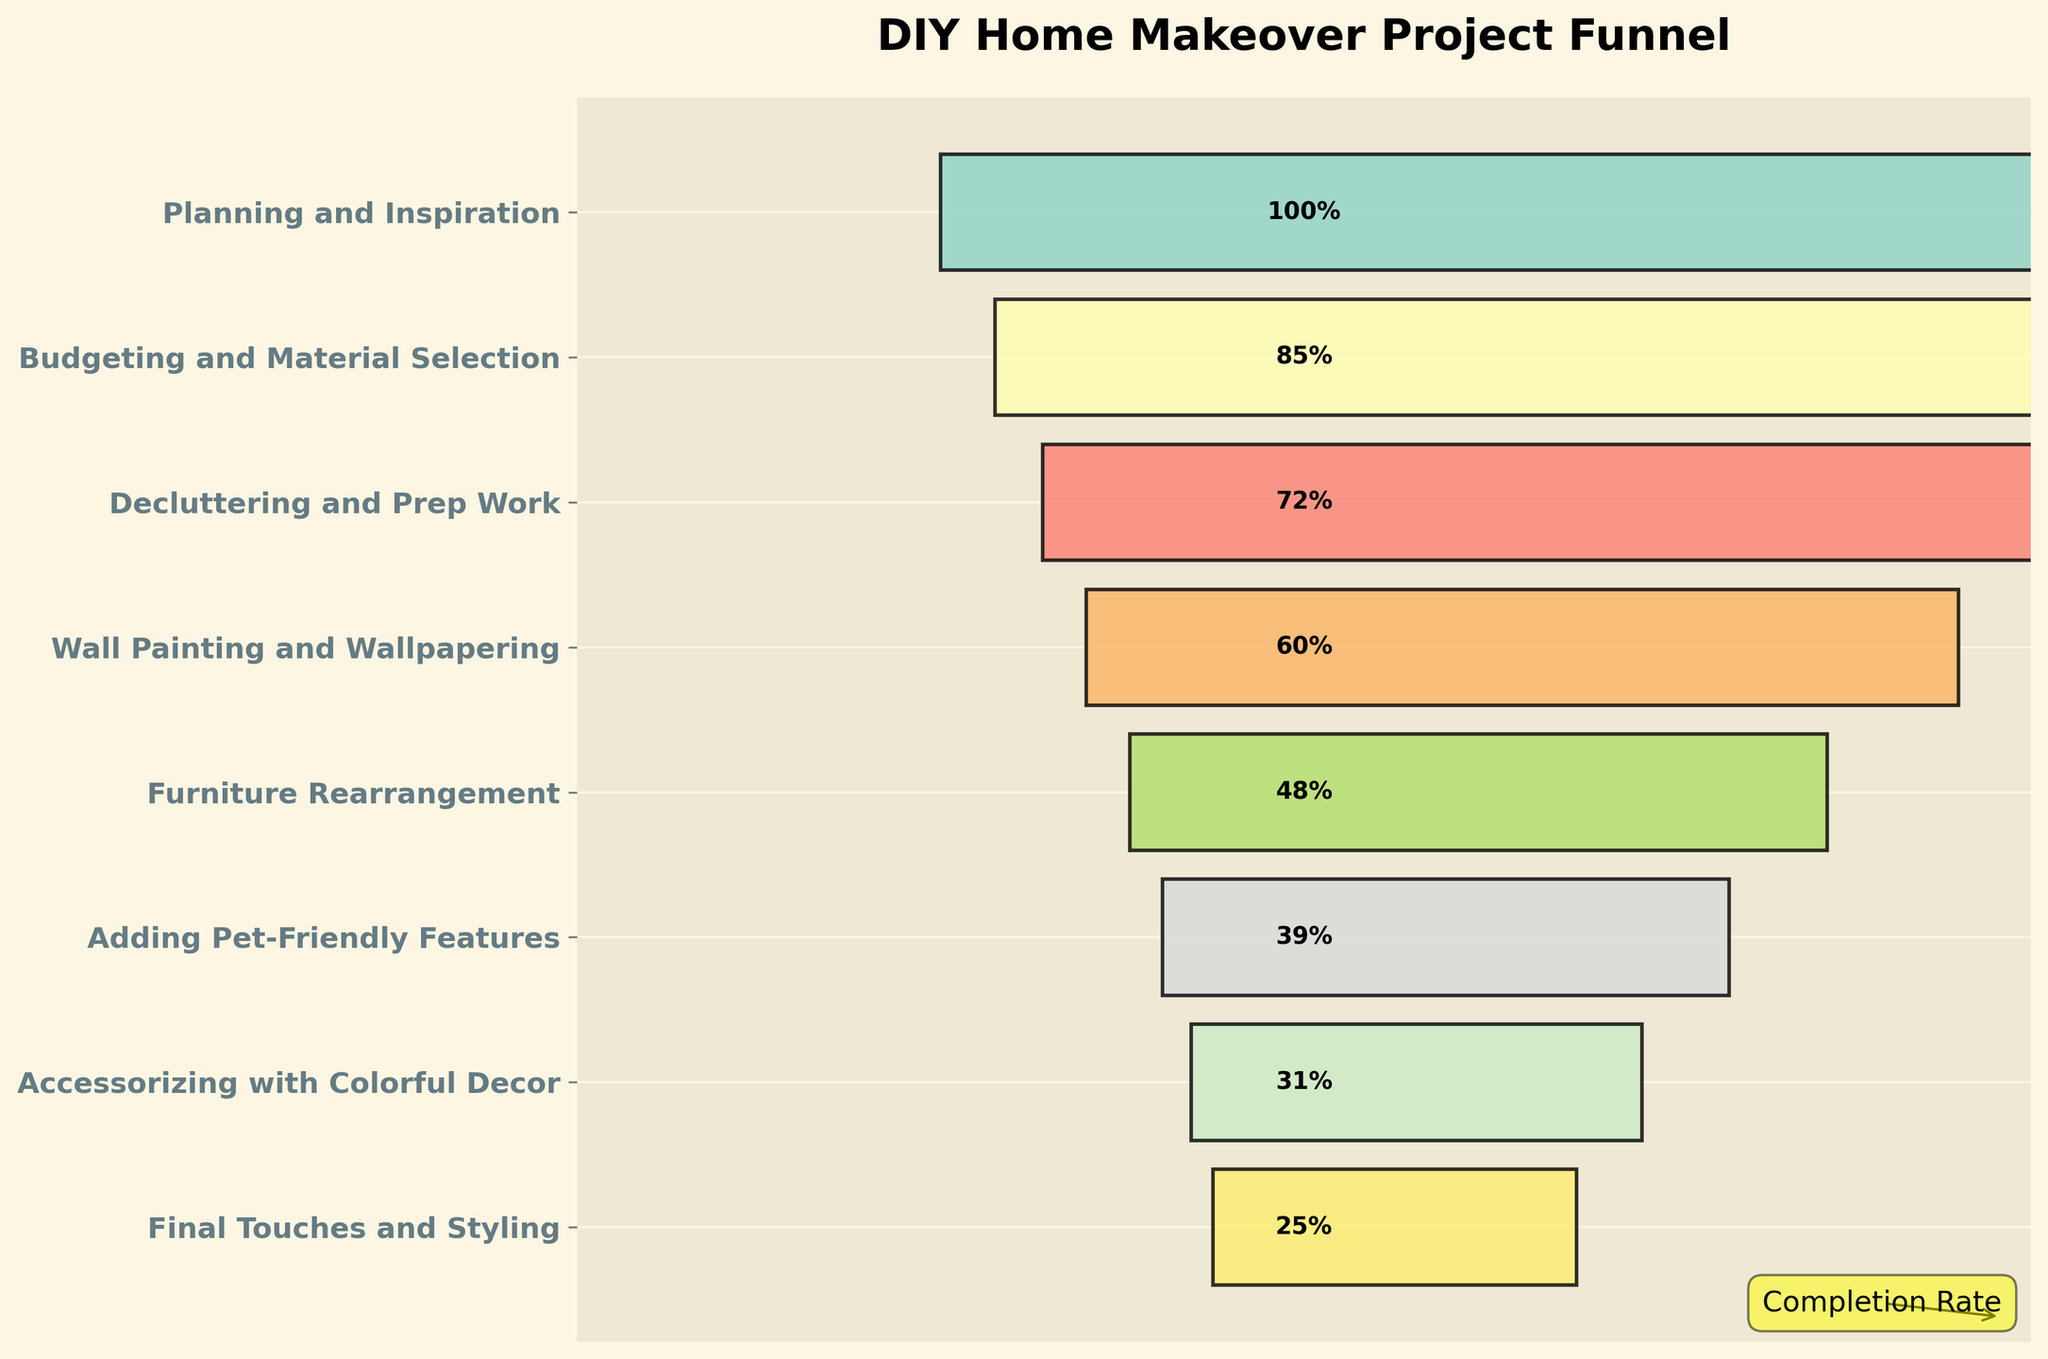What is the title of the figure? The title is usually located at the top of the plot and provides an overview of what the figure represents.
Answer: DIY Home Makeover Project Funnel What is the completion rate for the stage 'Decluttering and Prep Work'? Locate the bar for 'Decluttering and Prep Work' on the y-axis and read the completion rate percentage labeled on it.
Answer: 72% Which stage has the lowest completion rate? Identify the bar with the smallest width and read its corresponding stage on the y-axis.
Answer: Final Touches and Styling How many stages are displayed in the funnel chart? Count the number of distinct stages listed on the y-axis of the plot.
Answer: 8 At which stage do the completion rates drop below 50%? Identify the stage on the y-axis just before the bars' widths become less than half, which indicates a 50% completion rate.
Answer: Furniture Rearrangement What is the average completion rate across all stages? Sum up all the completion rates and divide by the number of stages: (100 + 85 + 72 + 60 + 48 + 39 + 31 + 25)/8.
Answer: 57.5% By what percentage does the completion rate for 'Wall Painting and Wallpapering' exceed that of 'Adding Pet-Friendly Features'? Subtract the completion rate of 'Adding Pet-Friendly Features' from 'Wall Painting and Wallpapering' and find the percentage difference: (60 - 39).
Answer: 21% What is the difference between the highest and lowest completion rates shown in the chart? Subtract the lowest completion rate (Final Touches and Styling) from the highest completion rate (Planning and Inspiration): 100 - 25.
Answer: 75% What percentage of completion rate is lost between 'Planning and Inspiration' and 'Final Touches and Styling'? Calculate the percentage difference from the first to the last stage: (100 - 25).
Answer: 75% 